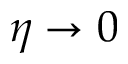Convert formula to latex. <formula><loc_0><loc_0><loc_500><loc_500>\eta \to 0</formula> 